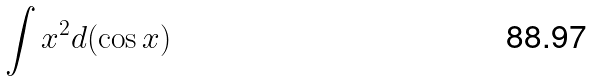Convert formula to latex. <formula><loc_0><loc_0><loc_500><loc_500>\int x ^ { 2 } d ( \cos x )</formula> 